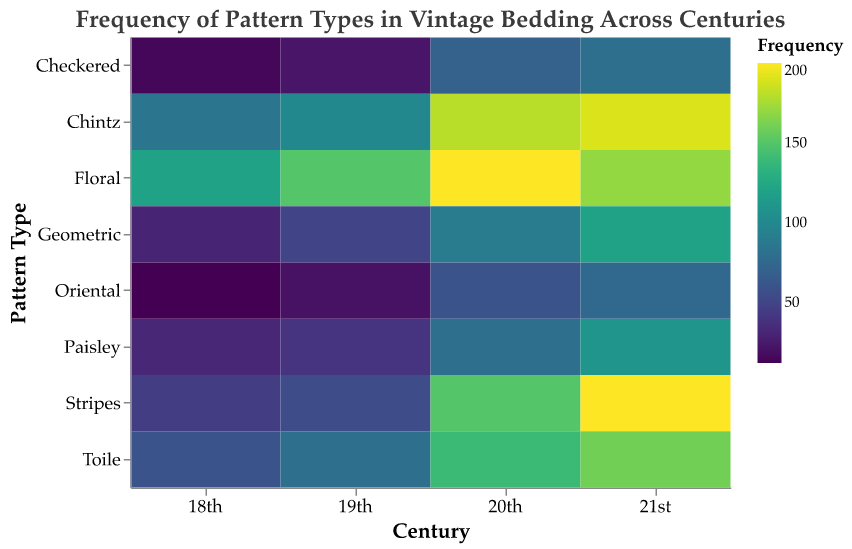What is the title of the heatmap? The title of the heatmap is usually displayed prominently at the top of the chart and is used to describe what the figure represents. In this case, you can refer to the title text for the information.
Answer: Frequency of Pattern Types in Vintage Bedding Across Centuries Which century has the highest frequency of Floral patterns? To find the century with the highest frequency of Floral patterns, look for the century label on the x-axis and identify the corresponding color indicating high frequency for the Flora row. The legend helps interpret the exact quantity.
Answer: 20th How does the frequency of Geometric patterns change from the 19th to the 21st century? To answer this comparison question, compare the frequency values of Geometric patterns between the 19th and the 21st century and note the difference.
Answer: Increases from 50 to 120 Which pattern type had the least frequency in the 18th century? To determine which pattern type had the least frequency in the 18th century, look for the smallest numerical value or the lightest color shade corresponding to the 18th century.
Answer: Oriental What is the sum of frequency values for Chintz patterns across all centuries? To calculate the sum, add up the frequency values of Chintz patterns for each century: 85 (18th) + 100 (19th) + 180 (20th) + 190 (21st) = 555.
Answer: 555 How does the popularity of Stripes patterns vary over the centuries? Observe the frequency values (color intensity) of the Stripes row across the centuries. From the 18th to the 21st century, Stripes patterns show a significant increase.
Answer: Increases Which century has the highest total frequency for all pattern types? To find this, sum the frequency values for all pattern types in each century. The century with the highest total sum represents the highest overall frequency.
Answer: 21st What is the difference in the frequency of Toile patterns between the 18th and the 20th centuries? Compare the frequency values of Toile patterns for both centuries: 140 (20th) - 60 (18th) gives the difference.
Answer: 80 What pattern type shows the most significant increase in frequency from the 18th to the 21st century? Compare the frequency changes from the 18th to the 21st century across all pattern types. Stripes show a significant increase from 45 (18th) to 200 (21st).
Answer: Stripes How many different pattern types are analyzed in the heatmap? Count the distinct pattern types listed along the y-axis or in the legend.
Answer: 8 